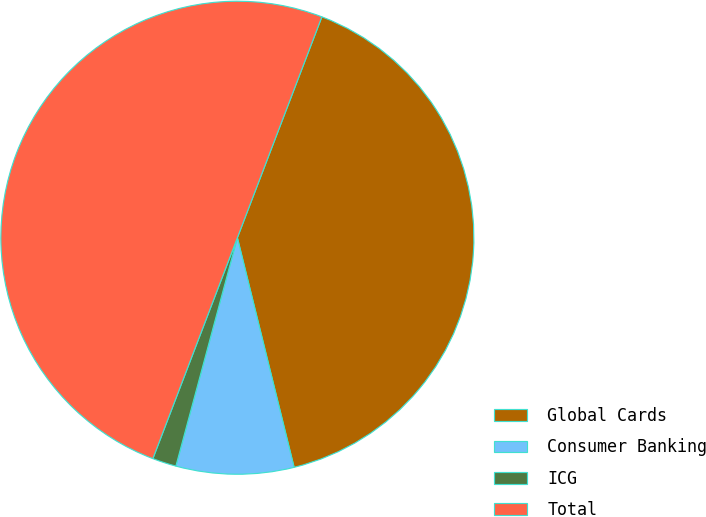Convert chart. <chart><loc_0><loc_0><loc_500><loc_500><pie_chart><fcel>Global Cards<fcel>Consumer Banking<fcel>ICG<fcel>Total<nl><fcel>40.33%<fcel>8.04%<fcel>1.63%<fcel>50.0%<nl></chart> 